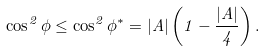<formula> <loc_0><loc_0><loc_500><loc_500>\cos ^ { 2 } \phi \leq \cos ^ { 2 } \phi ^ { \ast } = | A | \left ( 1 - \frac { | A | } { 4 } \right ) .</formula> 